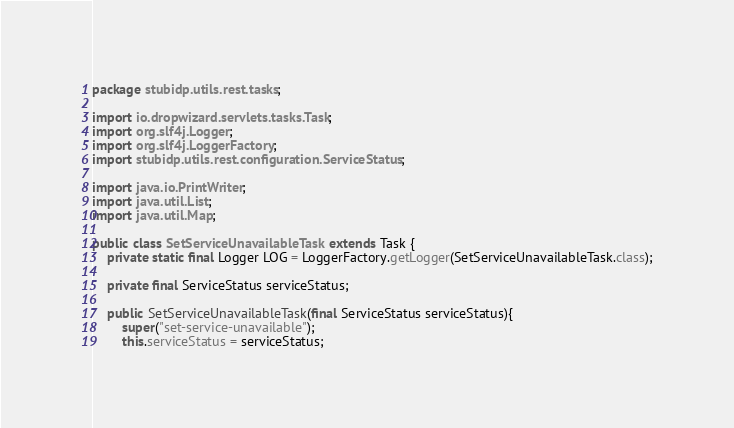Convert code to text. <code><loc_0><loc_0><loc_500><loc_500><_Java_>package stubidp.utils.rest.tasks;

import io.dropwizard.servlets.tasks.Task;
import org.slf4j.Logger;
import org.slf4j.LoggerFactory;
import stubidp.utils.rest.configuration.ServiceStatus;

import java.io.PrintWriter;
import java.util.List;
import java.util.Map;

public class SetServiceUnavailableTask extends Task {
    private static final Logger LOG = LoggerFactory.getLogger(SetServiceUnavailableTask.class);

    private final ServiceStatus serviceStatus;

    public SetServiceUnavailableTask(final ServiceStatus serviceStatus){
        super("set-service-unavailable");
        this.serviceStatus = serviceStatus;</code> 